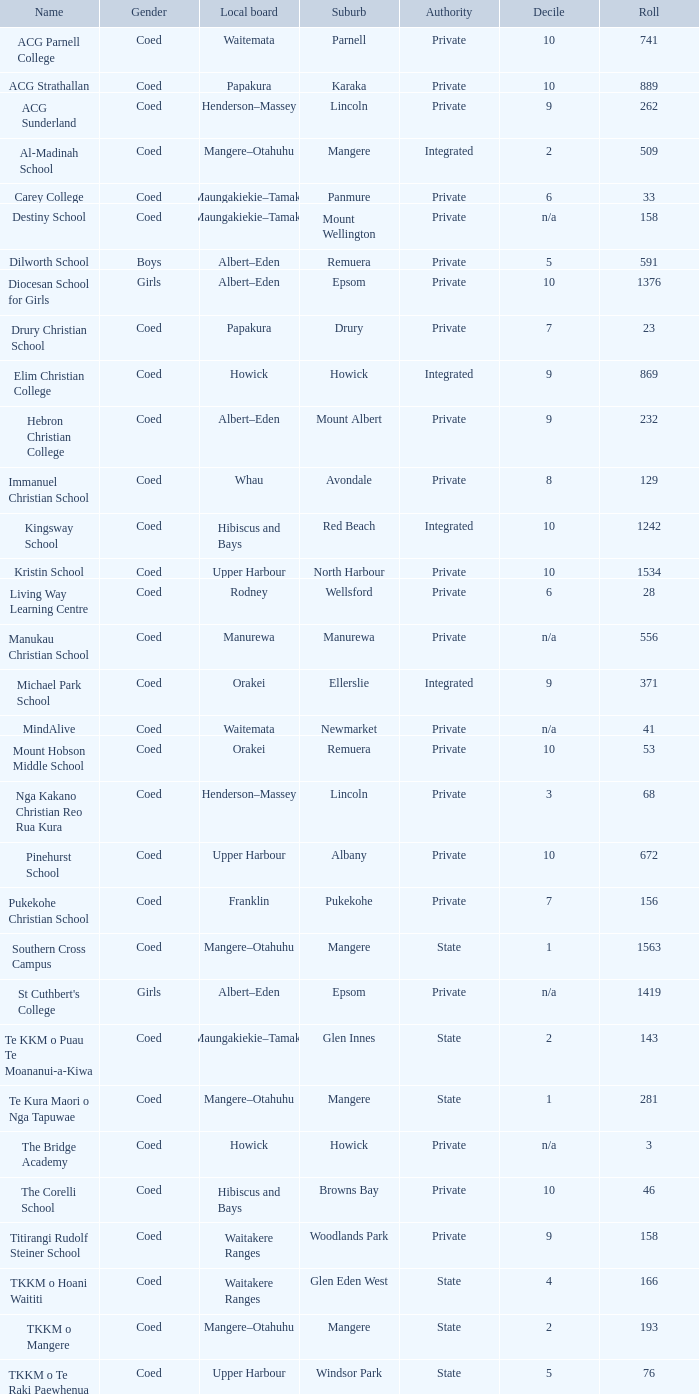Write the full table. {'header': ['Name', 'Gender', 'Local board', 'Suburb', 'Authority', 'Decile', 'Roll'], 'rows': [['ACG Parnell College', 'Coed', 'Waitemata', 'Parnell', 'Private', '10', '741'], ['ACG Strathallan', 'Coed', 'Papakura', 'Karaka', 'Private', '10', '889'], ['ACG Sunderland', 'Coed', 'Henderson–Massey', 'Lincoln', 'Private', '9', '262'], ['Al-Madinah School', 'Coed', 'Mangere–Otahuhu', 'Mangere', 'Integrated', '2', '509'], ['Carey College', 'Coed', 'Maungakiekie–Tamaki', 'Panmure', 'Private', '6', '33'], ['Destiny School', 'Coed', 'Maungakiekie–Tamaki', 'Mount Wellington', 'Private', 'n/a', '158'], ['Dilworth School', 'Boys', 'Albert–Eden', 'Remuera', 'Private', '5', '591'], ['Diocesan School for Girls', 'Girls', 'Albert–Eden', 'Epsom', 'Private', '10', '1376'], ['Drury Christian School', 'Coed', 'Papakura', 'Drury', 'Private', '7', '23'], ['Elim Christian College', 'Coed', 'Howick', 'Howick', 'Integrated', '9', '869'], ['Hebron Christian College', 'Coed', 'Albert–Eden', 'Mount Albert', 'Private', '9', '232'], ['Immanuel Christian School', 'Coed', 'Whau', 'Avondale', 'Private', '8', '129'], ['Kingsway School', 'Coed', 'Hibiscus and Bays', 'Red Beach', 'Integrated', '10', '1242'], ['Kristin School', 'Coed', 'Upper Harbour', 'North Harbour', 'Private', '10', '1534'], ['Living Way Learning Centre', 'Coed', 'Rodney', 'Wellsford', 'Private', '6', '28'], ['Manukau Christian School', 'Coed', 'Manurewa', 'Manurewa', 'Private', 'n/a', '556'], ['Michael Park School', 'Coed', 'Orakei', 'Ellerslie', 'Integrated', '9', '371'], ['MindAlive', 'Coed', 'Waitemata', 'Newmarket', 'Private', 'n/a', '41'], ['Mount Hobson Middle School', 'Coed', 'Orakei', 'Remuera', 'Private', '10', '53'], ['Nga Kakano Christian Reo Rua Kura', 'Coed', 'Henderson–Massey', 'Lincoln', 'Private', '3', '68'], ['Pinehurst School', 'Coed', 'Upper Harbour', 'Albany', 'Private', '10', '672'], ['Pukekohe Christian School', 'Coed', 'Franklin', 'Pukekohe', 'Private', '7', '156'], ['Southern Cross Campus', 'Coed', 'Mangere–Otahuhu', 'Mangere', 'State', '1', '1563'], ["St Cuthbert's College", 'Girls', 'Albert–Eden', 'Epsom', 'Private', 'n/a', '1419'], ['Te KKM o Puau Te Moananui-a-Kiwa', 'Coed', 'Maungakiekie–Tamaki', 'Glen Innes', 'State', '2', '143'], ['Te Kura Maori o Nga Tapuwae', 'Coed', 'Mangere–Otahuhu', 'Mangere', 'State', '1', '281'], ['The Bridge Academy', 'Coed', 'Howick', 'Howick', 'Private', 'n/a', '3'], ['The Corelli School', 'Coed', 'Hibiscus and Bays', 'Browns Bay', 'Private', '10', '46'], ['Titirangi Rudolf Steiner School', 'Coed', 'Waitakere Ranges', 'Woodlands Park', 'Private', '9', '158'], ['TKKM o Hoani Waititi', 'Coed', 'Waitakere Ranges', 'Glen Eden West', 'State', '4', '166'], ['TKKM o Mangere', 'Coed', 'Mangere–Otahuhu', 'Mangere', 'State', '2', '193'], ['TKKM o Te Raki Paewhenua', 'Coed', 'Upper Harbour', 'Windsor Park', 'State', '5', '76'], ['Tyndale Park Christian School', 'Coed', 'Howick', 'Flat Bush', 'Private', 'n/a', '120']]} Which name signifies private authority and the hibiscus and bays local board? The Corelli School. 